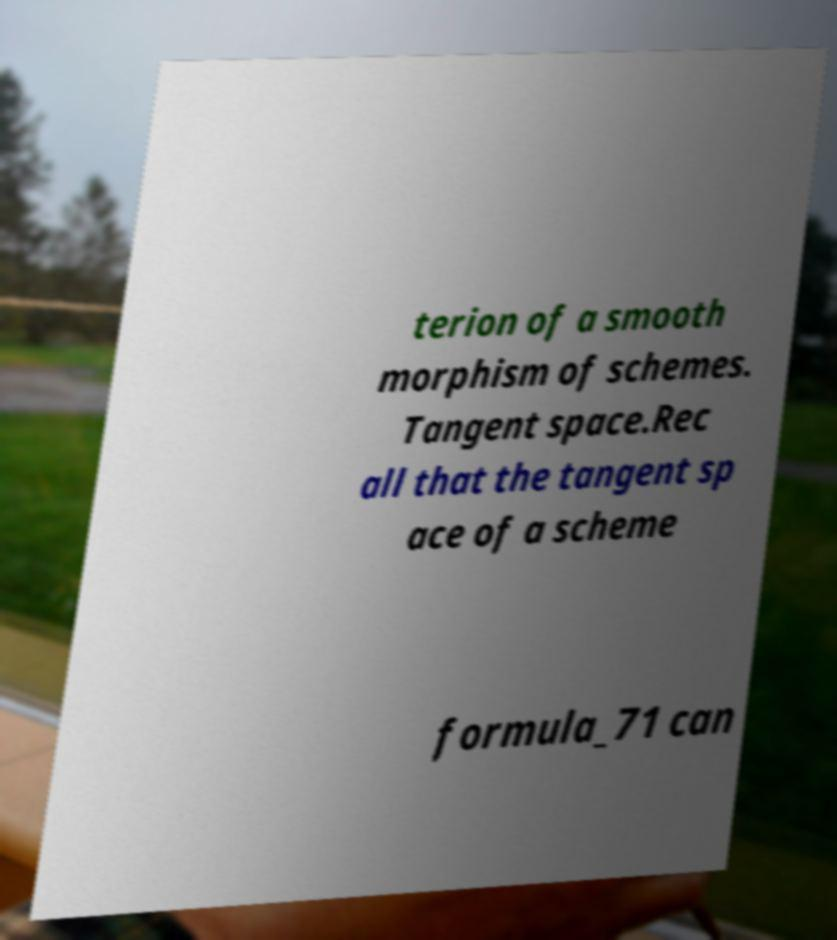There's text embedded in this image that I need extracted. Can you transcribe it verbatim? terion of a smooth morphism of schemes. Tangent space.Rec all that the tangent sp ace of a scheme formula_71 can 